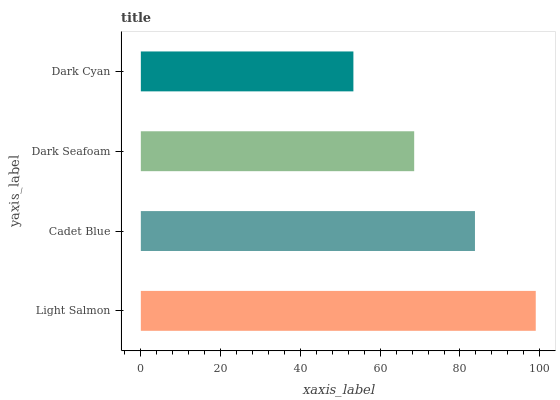Is Dark Cyan the minimum?
Answer yes or no. Yes. Is Light Salmon the maximum?
Answer yes or no. Yes. Is Cadet Blue the minimum?
Answer yes or no. No. Is Cadet Blue the maximum?
Answer yes or no. No. Is Light Salmon greater than Cadet Blue?
Answer yes or no. Yes. Is Cadet Blue less than Light Salmon?
Answer yes or no. Yes. Is Cadet Blue greater than Light Salmon?
Answer yes or no. No. Is Light Salmon less than Cadet Blue?
Answer yes or no. No. Is Cadet Blue the high median?
Answer yes or no. Yes. Is Dark Seafoam the low median?
Answer yes or no. Yes. Is Dark Seafoam the high median?
Answer yes or no. No. Is Light Salmon the low median?
Answer yes or no. No. 